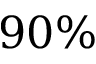Convert formula to latex. <formula><loc_0><loc_0><loc_500><loc_500>9 0 \%</formula> 